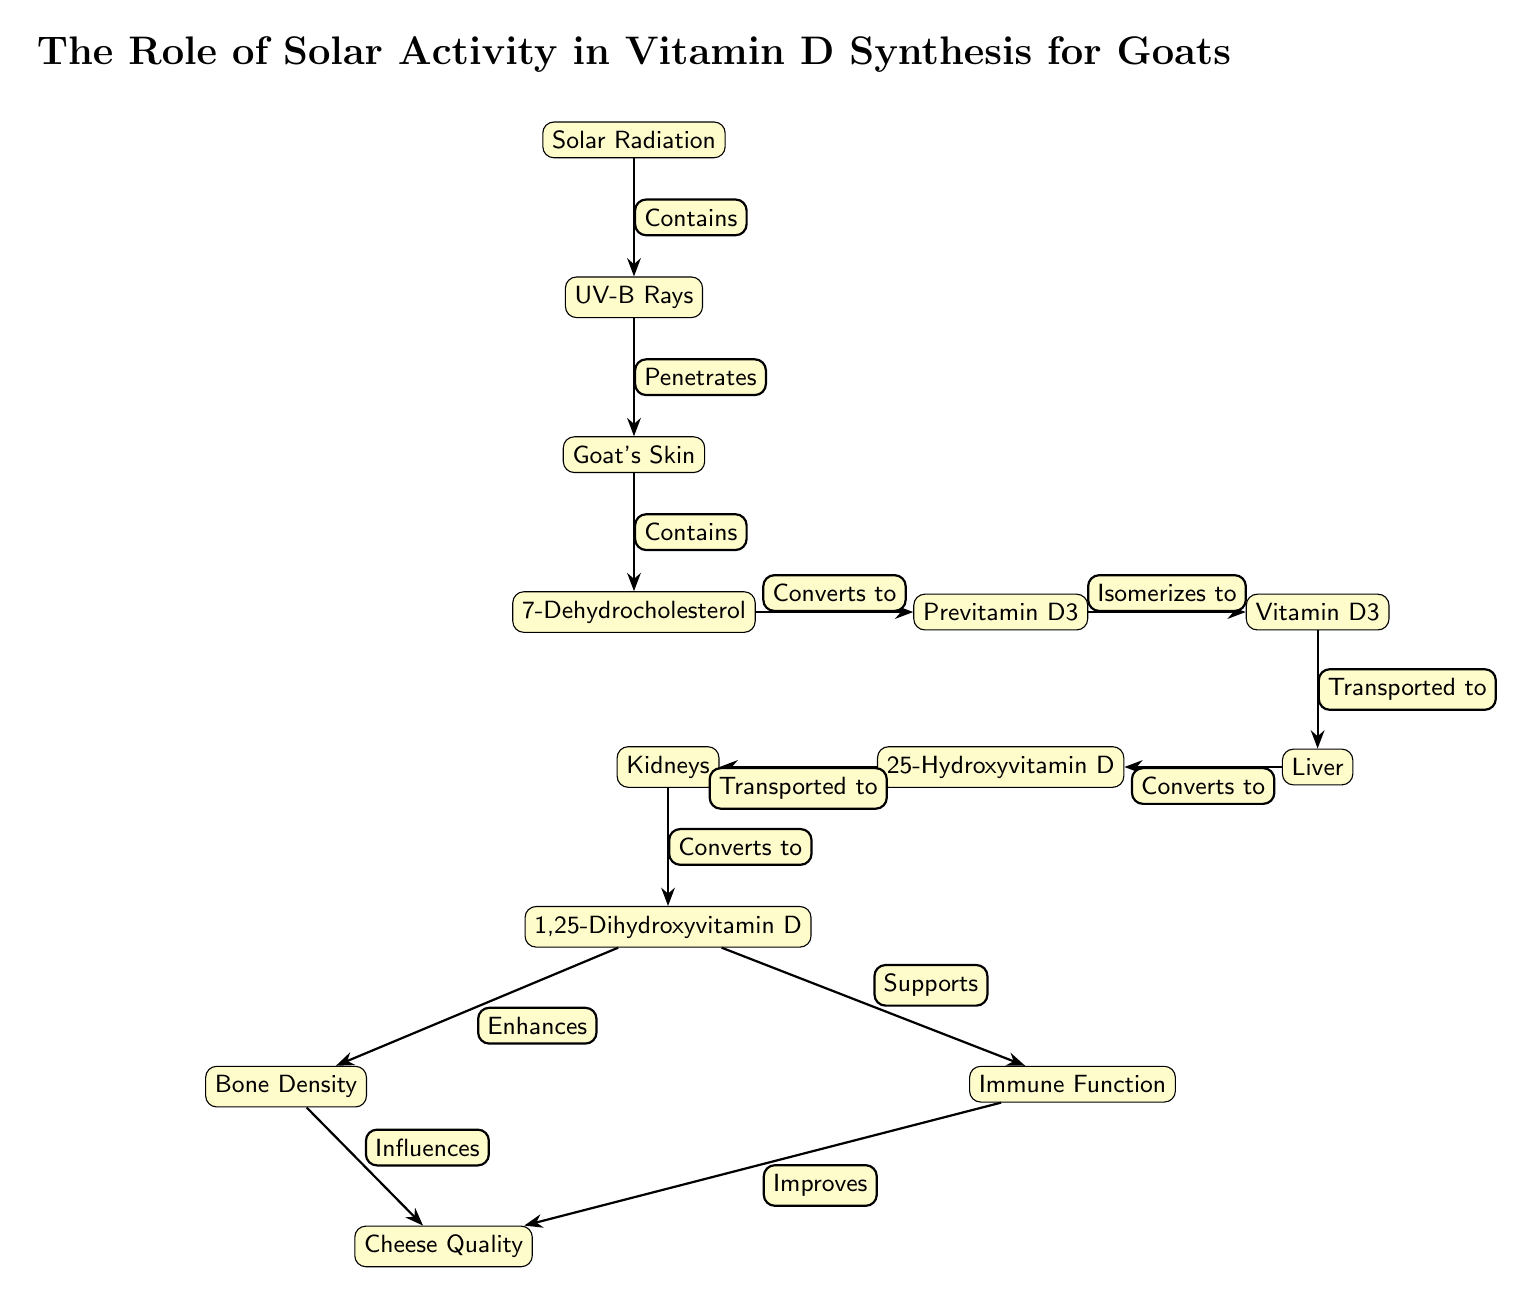What is the first node in the diagram? The first node is labeled "Solar Radiation," which is the starting point of the flow depicting the process of vitamin D synthesis in goats.
Answer: Solar Radiation How many nodes are present in the diagram? To find the total number of nodes, we count each distinct node listed: Solar Radiation, UV-B Rays, Goat's Skin, 7-Dehydrocholesterol, Previtamin D3, Vitamin D3, Liver, 25-Hydroxyvitamin D, Kidneys, 1,25-Dihydroxyvitamin D, Bone Density, Immune Function, Cheese Quality. This sums up to 13 nodes.
Answer: 13 What does UV-B Rays do in the process? The diagram specifies that UV-B Rays "Penetrates" the Goat's Skin, which indicates their role in initiating the subsequent vitamin D synthesis process.
Answer: Penetrates Which nodes are involved in the conversion of vitamin D? The nodes involved in the conversion process are Vitamin D3 (that is transported to Liver) and then from Liver to 25-Hydroxyvitamin D, and finally from 25-Hydroxyvitamin D to Kidneys, which converts it to 1,25-Dihydroxyvitamin D.
Answer: Vitamin D3, Liver, Kidneys What is the relationship between 1,25-Dihydroxyvitamin D and Cheese Quality? The diagram shows that 1,25-Dihydroxyvitamin D "Enhances" Bone Density and "Supports" Immune Function, both of which "Influences" Cheese Quality, indicating a connection between these components and the quality of cheese derived from goats.
Answer: Influences How does the process affect immune function? The diagram indicates that 1,25-Dihydroxyvitamin D "Supports" Immune Function, which highlights the importance of vitamin D in the overall immune health of goats and indirectly to the quality of the cheese they produce.
Answer: Supports What substance is converted into Previtamin D3? The 7-Dehydrocholesterol is directly mentioned as being "Converted to" Previtamin D3, indicating its critical role in the vitamin D synthesis pathway.
Answer: 7-Dehydrocholesterol What are the final products or outcomes represented in the diagram? The final outcomes depicted in the diagram are Bone Density, Immune Function, and Cheese Quality, suggesting the health and nutritional implications of solar activity on goats and their cheese.
Answer: Bone Density, Immune Function, Cheese Quality 